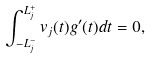Convert formula to latex. <formula><loc_0><loc_0><loc_500><loc_500>\int _ { - L _ { j } ^ { - } } ^ { L _ { j } ^ { + } } v _ { j } ( t ) g ^ { \prime } ( t ) d t = 0 ,</formula> 